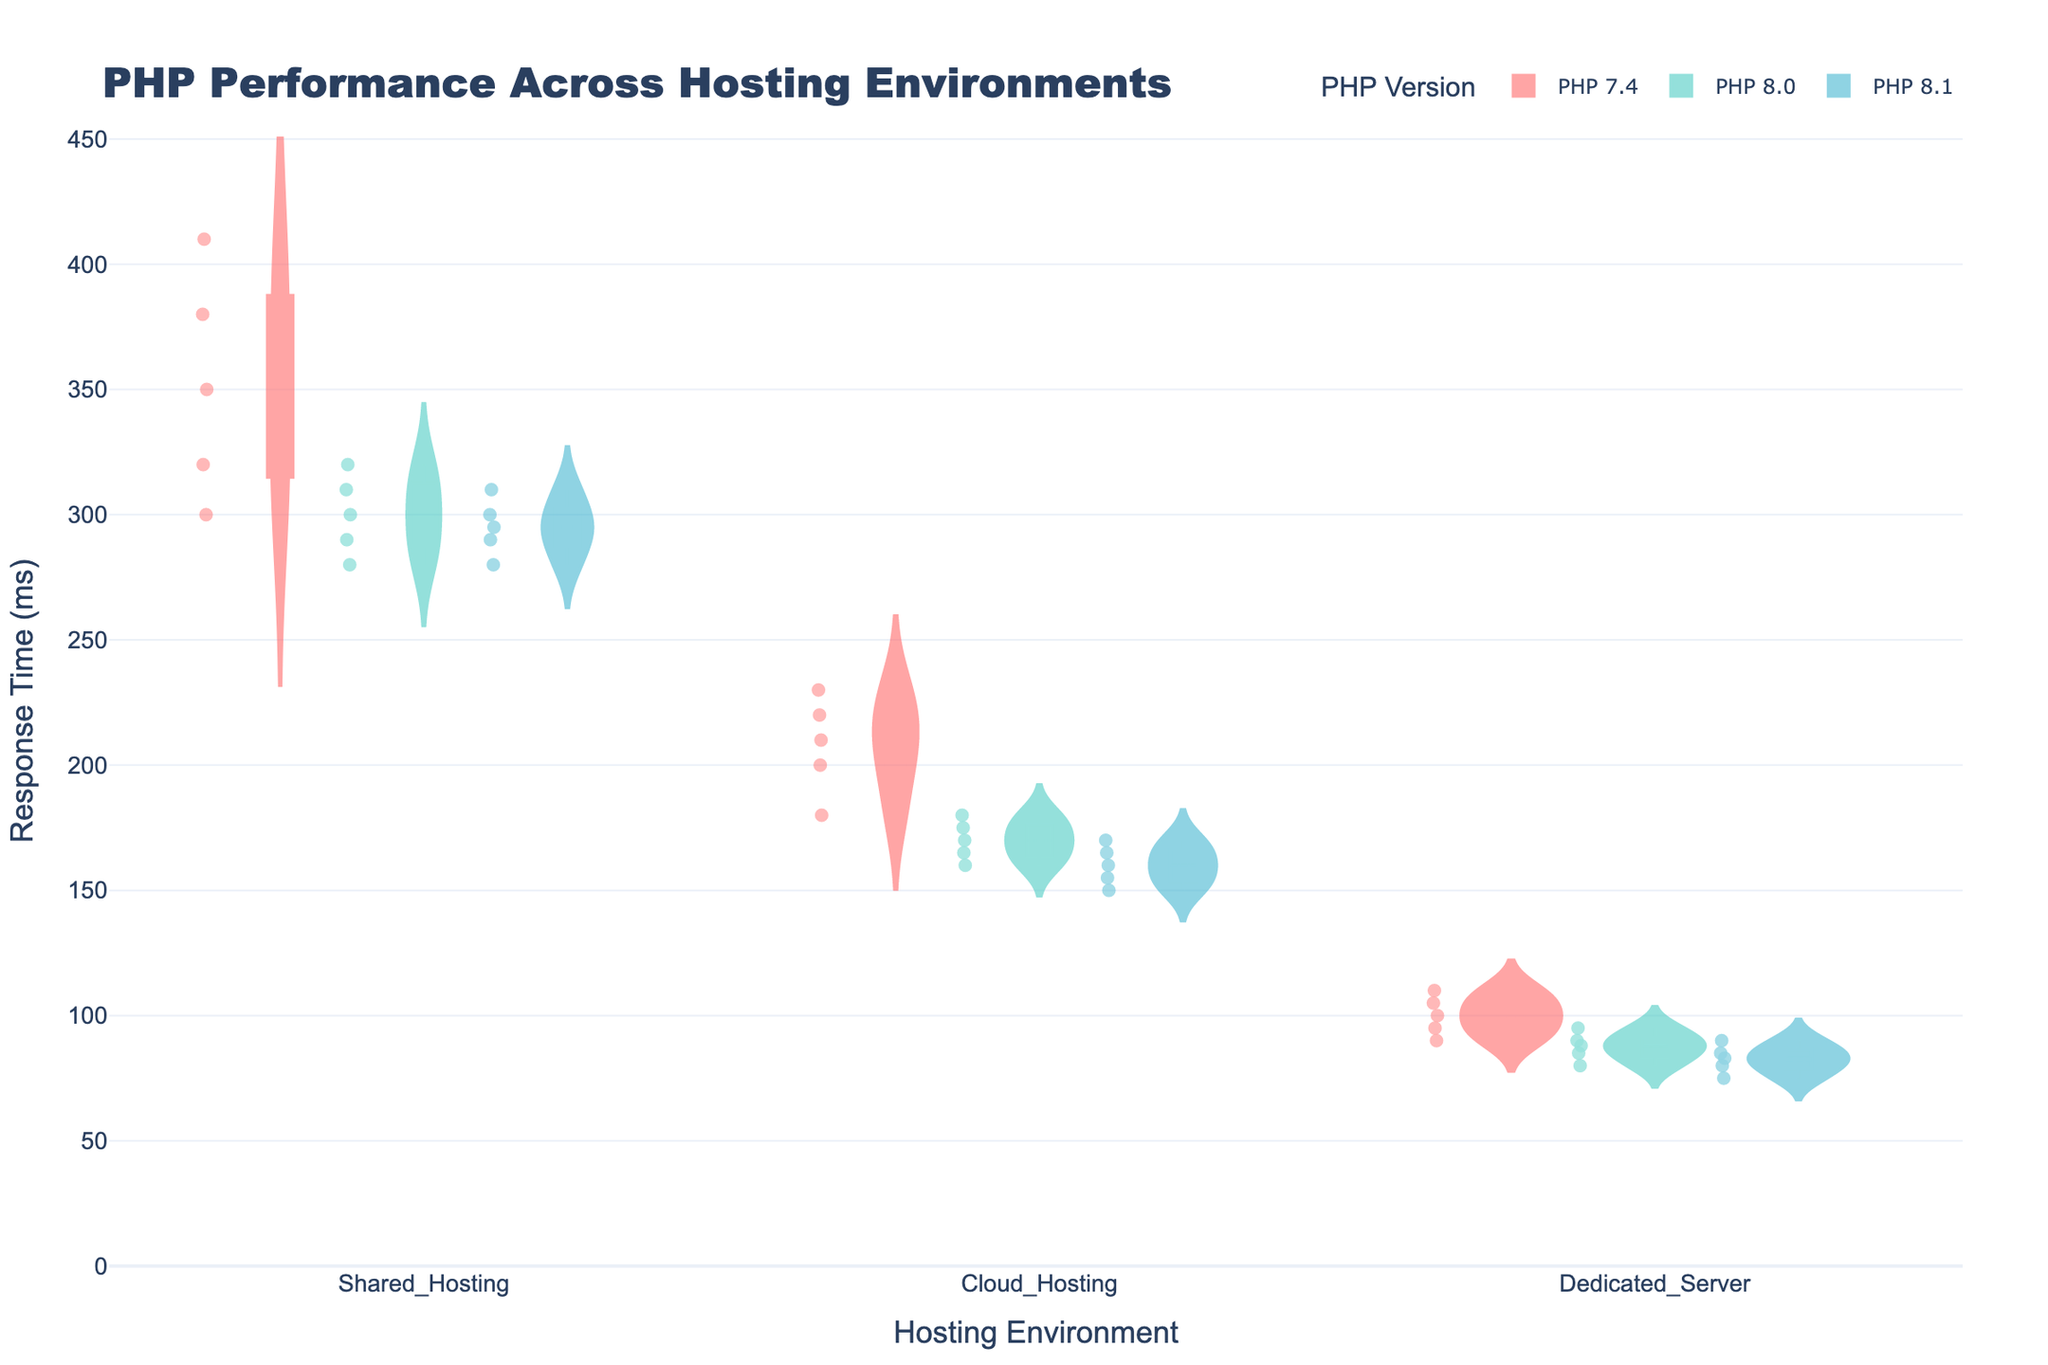What is the title of the chart? The title is generally located at the top of the chart and is written in larger font size for emphasis. In this case, it's "PHP Performance Across Hosting Environments".
Answer: PHP Performance Across Hosting Environments What is the median response time for PHP 8.0 on Cloud Hosting? To find the median, look at the horizontal line inside the box plot overlaid on the violin for PHP 8.0 within the Cloud Hosting category. This line represents the median.
Answer: 170 ms Which hosting environment has the highest median response time for PHP 7.4? For PHP 7.4, look at the center lines inside the box plots for each hosting environment. The one with the highest median centerline indicates the highest median response time.
Answer: Shared Hosting Is the distribution of response times for PHP 7.4 on Dedicated Server wider or narrower compared to PHP 8.1 on Shared Hosting? Check the width of the violin plots. A wider violin indicates a broader distribution. Compare the width of PHP 7.4 on Dedicated Server with PHP 8.1 on Shared Hosting.
Answer: Narrower What is the median response time for PHP 8.1 on Dedicated Server? Check the horizontal line inside the box plot overlaid on the violin for PHP 8.1 within the Dedicated Server category. This line represents the median.
Answer: 83 ms Compare the response times for PHP 7.4 and PHP 8.1 on Shared Hosting. Which PHP version has a lower median response time? Look at the center lines inside the box plots for both PHP 7.4 and PHP 8.1 within the Shared Hosting category. The one with the lower centerline has the lower median response time.
Answer: PHP 8.1 Which PHP version has the lowest median response time across all hosting environments? Compare the center lines inside the box plots for each PHP version across all hosting environments. The lowest line represents the lowest median response time.
Answer: PHP 8.0 Is there more variability in response times for PHP 8.0 in Cloud Hosting or Dedicated Server? Variability can be observed by the spread of the violin and the length of the whiskers in the box plot. Compare these for PHP 8.0 in Cloud Hosting and Dedicated Server.
Answer: Cloud Hosting Are the majority of response times for PHP 7.4 in Cloud Hosting below 250 ms? Observe the area covered by the violin plot for PHP 7.4 in Cloud Hosting. If most of the data points fall below the 250 ms mark, the majority are below that threshold.
Answer: Yes 